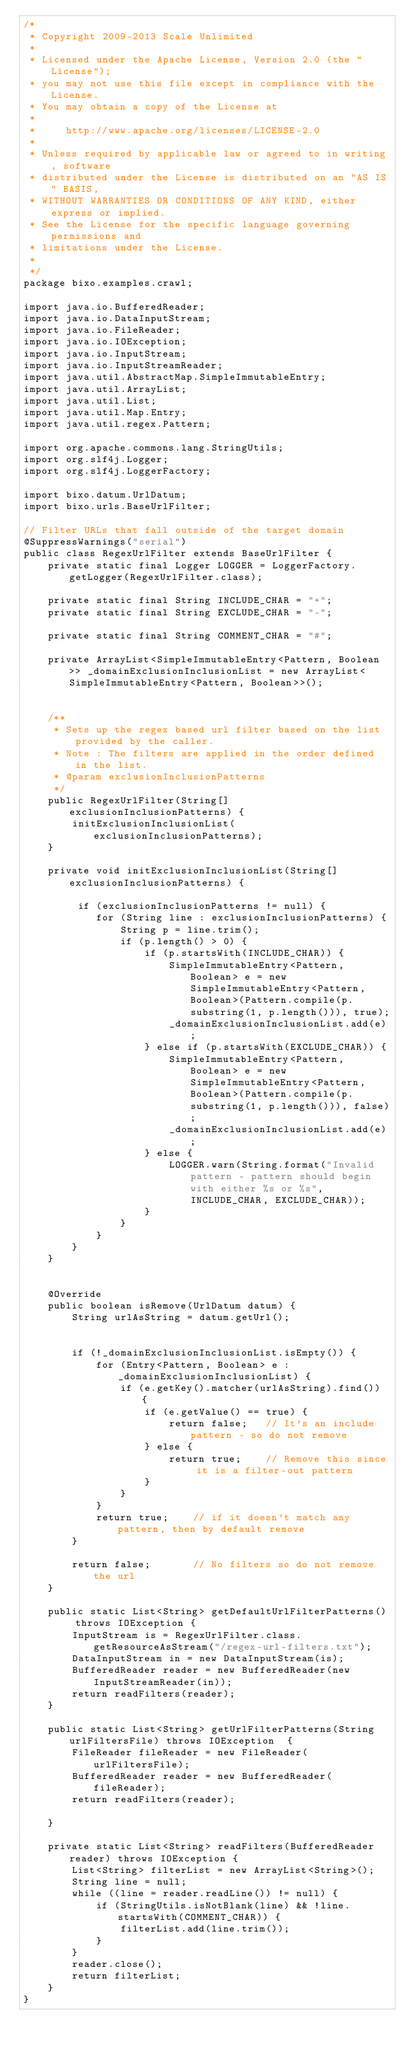<code> <loc_0><loc_0><loc_500><loc_500><_Java_>/*
 * Copyright 2009-2013 Scale Unlimited
 *
 * Licensed under the Apache License, Version 2.0 (the "License");
 * you may not use this file except in compliance with the License.
 * You may obtain a copy of the License at
 *
 *     http://www.apache.org/licenses/LICENSE-2.0
 *
 * Unless required by applicable law or agreed to in writing, software
 * distributed under the License is distributed on an "AS IS" BASIS,
 * WITHOUT WARRANTIES OR CONDITIONS OF ANY KIND, either express or implied.
 * See the License for the specific language governing permissions and
 * limitations under the License.
 *
 */
package bixo.examples.crawl;

import java.io.BufferedReader;
import java.io.DataInputStream;
import java.io.FileReader;
import java.io.IOException;
import java.io.InputStream;
import java.io.InputStreamReader;
import java.util.AbstractMap.SimpleImmutableEntry;
import java.util.ArrayList;
import java.util.List;
import java.util.Map.Entry;
import java.util.regex.Pattern;

import org.apache.commons.lang.StringUtils;
import org.slf4j.Logger;
import org.slf4j.LoggerFactory;

import bixo.datum.UrlDatum;
import bixo.urls.BaseUrlFilter;

// Filter URLs that fall outside of the target domain
@SuppressWarnings("serial")
public class RegexUrlFilter extends BaseUrlFilter {
    private static final Logger LOGGER = LoggerFactory.getLogger(RegexUrlFilter.class);

    private static final String INCLUDE_CHAR = "+";
    private static final String EXCLUDE_CHAR = "-";

    private static final String COMMENT_CHAR = "#";

    private ArrayList<SimpleImmutableEntry<Pattern, Boolean>> _domainExclusionInclusionList = new ArrayList<SimpleImmutableEntry<Pattern, Boolean>>();


    /**
     * Sets up the regex based url filter based on the list provided by the caller.
     * Note : The filters are applied in the order defined in the list.
     * @param exclusionInclusionPatterns
     */
    public RegexUrlFilter(String[] exclusionInclusionPatterns) {
        initExclusionInclusionList(exclusionInclusionPatterns);
    }
    
    private void initExclusionInclusionList(String[] exclusionInclusionPatterns) {
        
         if (exclusionInclusionPatterns != null) {
            for (String line : exclusionInclusionPatterns) {
                String p = line.trim();
                if (p.length() > 0) {
                    if (p.startsWith(INCLUDE_CHAR)) {
                        SimpleImmutableEntry<Pattern, Boolean> e = new SimpleImmutableEntry<Pattern, Boolean>(Pattern.compile(p.substring(1, p.length())), true);
                        _domainExclusionInclusionList.add(e);
                    } else if (p.startsWith(EXCLUDE_CHAR)) {
                        SimpleImmutableEntry<Pattern, Boolean> e = new SimpleImmutableEntry<Pattern, Boolean>(Pattern.compile(p.substring(1, p.length())), false);
                        _domainExclusionInclusionList.add(e);
                    } else {
                        LOGGER.warn(String.format("Invalid pattern - pattern should begin with either %s or %s", INCLUDE_CHAR, EXCLUDE_CHAR));
                    }
                }
            }
        } 
    }


    @Override
    public boolean isRemove(UrlDatum datum) {
        String urlAsString = datum.getUrl();
        
        
        if (!_domainExclusionInclusionList.isEmpty()) {
            for (Entry<Pattern, Boolean> e : _domainExclusionInclusionList) {
                if (e.getKey().matcher(urlAsString).find()) {
                    if (e.getValue() == true) {
                        return false;   // It's an include pattern - so do not remove
                    } else {
                        return true;    // Remove this since it is a filter-out pattern
                    }
                }
            }
            return true;    // if it doesn't match any pattern, then by default remove
        }
        
        return false;       // No filters so do not remove the url
    }
    
    public static List<String> getDefaultUrlFilterPatterns() throws IOException {
        InputStream is = RegexUrlFilter.class.getResourceAsStream("/regex-url-filters.txt");
        DataInputStream in = new DataInputStream(is);
        BufferedReader reader = new BufferedReader(new InputStreamReader(in));
        return readFilters(reader);
    }

    public static List<String> getUrlFilterPatterns(String urlFiltersFile) throws IOException  {
        FileReader fileReader = new FileReader(urlFiltersFile);
        BufferedReader reader = new BufferedReader(fileReader);
        return readFilters(reader);
        
    }

    private static List<String> readFilters(BufferedReader reader) throws IOException {
        List<String> filterList = new ArrayList<String>();
        String line = null;
        while ((line = reader.readLine()) != null) {
            if (StringUtils.isNotBlank(line) && !line.startsWith(COMMENT_CHAR)) {
                filterList.add(line.trim());
            }
        }
        reader.close();
        return filterList;
    }
}
</code> 